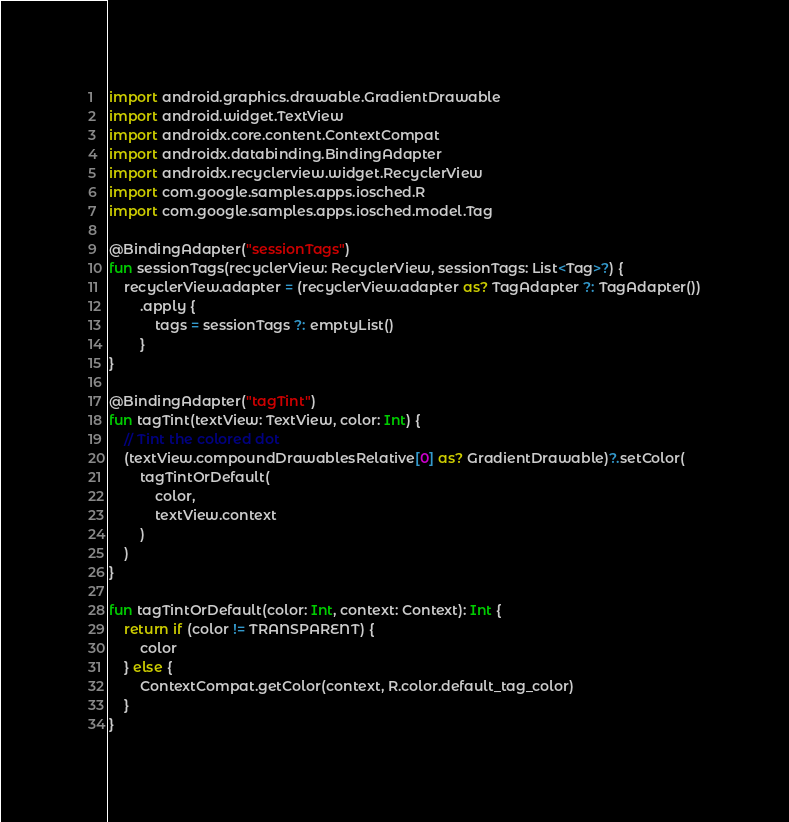Convert code to text. <code><loc_0><loc_0><loc_500><loc_500><_Kotlin_>import android.graphics.drawable.GradientDrawable
import android.widget.TextView
import androidx.core.content.ContextCompat
import androidx.databinding.BindingAdapter
import androidx.recyclerview.widget.RecyclerView
import com.google.samples.apps.iosched.R
import com.google.samples.apps.iosched.model.Tag

@BindingAdapter("sessionTags")
fun sessionTags(recyclerView: RecyclerView, sessionTags: List<Tag>?) {
    recyclerView.adapter = (recyclerView.adapter as? TagAdapter ?: TagAdapter())
        .apply {
            tags = sessionTags ?: emptyList()
        }
}

@BindingAdapter("tagTint")
fun tagTint(textView: TextView, color: Int) {
    // Tint the colored dot
    (textView.compoundDrawablesRelative[0] as? GradientDrawable)?.setColor(
        tagTintOrDefault(
            color,
            textView.context
        )
    )
}

fun tagTintOrDefault(color: Int, context: Context): Int {
    return if (color != TRANSPARENT) {
        color
    } else {
        ContextCompat.getColor(context, R.color.default_tag_color)
    }
}
</code> 